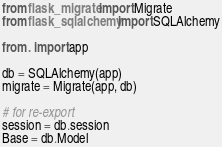<code> <loc_0><loc_0><loc_500><loc_500><_Python_>from flask_migrate import Migrate
from flask_sqlalchemy import SQLAlchemy

from . import app

db = SQLAlchemy(app)
migrate = Migrate(app, db)

# for re-export
session = db.session
Base = db.Model
</code> 